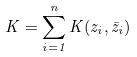<formula> <loc_0><loc_0><loc_500><loc_500>K = \sum _ { i = 1 } ^ { n } K ( z _ { i } , \bar { z } _ { i } )</formula> 